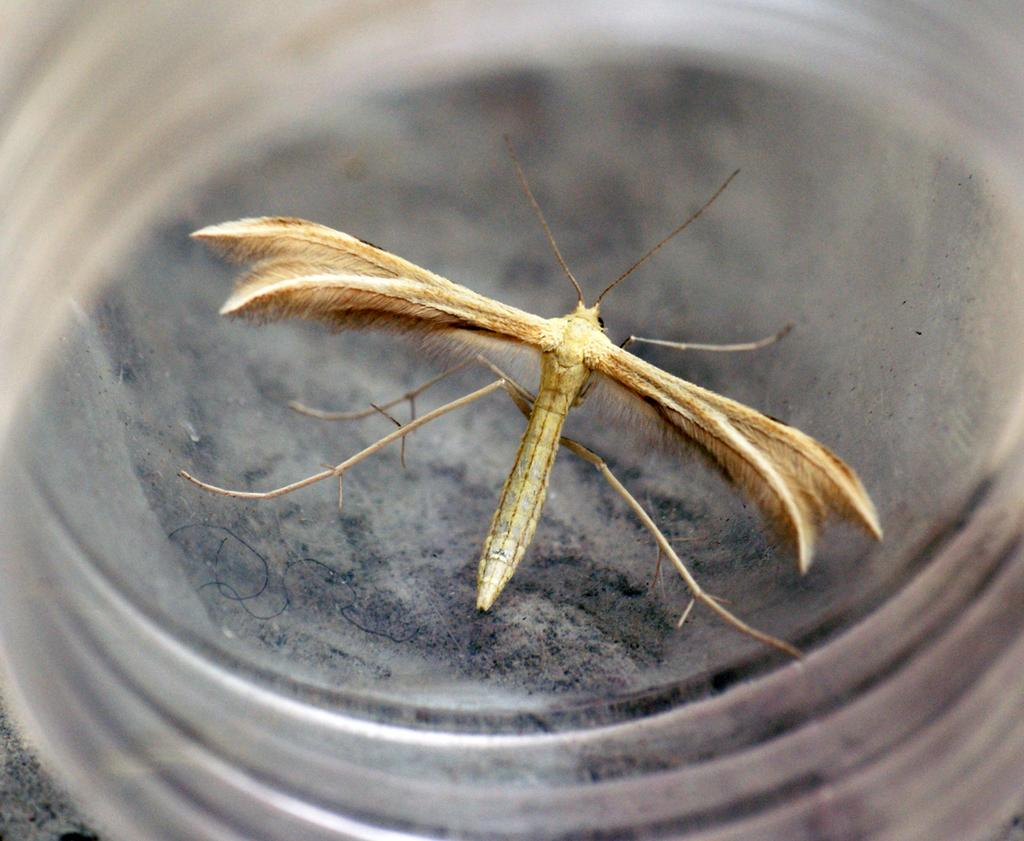What type of creature can be seen in the image? There is an insect in the image. Where is the insect located? The insect is on a glass object. What type of bag is visible in the image? There is no bag present in the image; it features an insect on a glass object. What kind of beast can be seen interacting with the insect in the image? There is no beast present in the image; only the insect and the glass object are visible. 